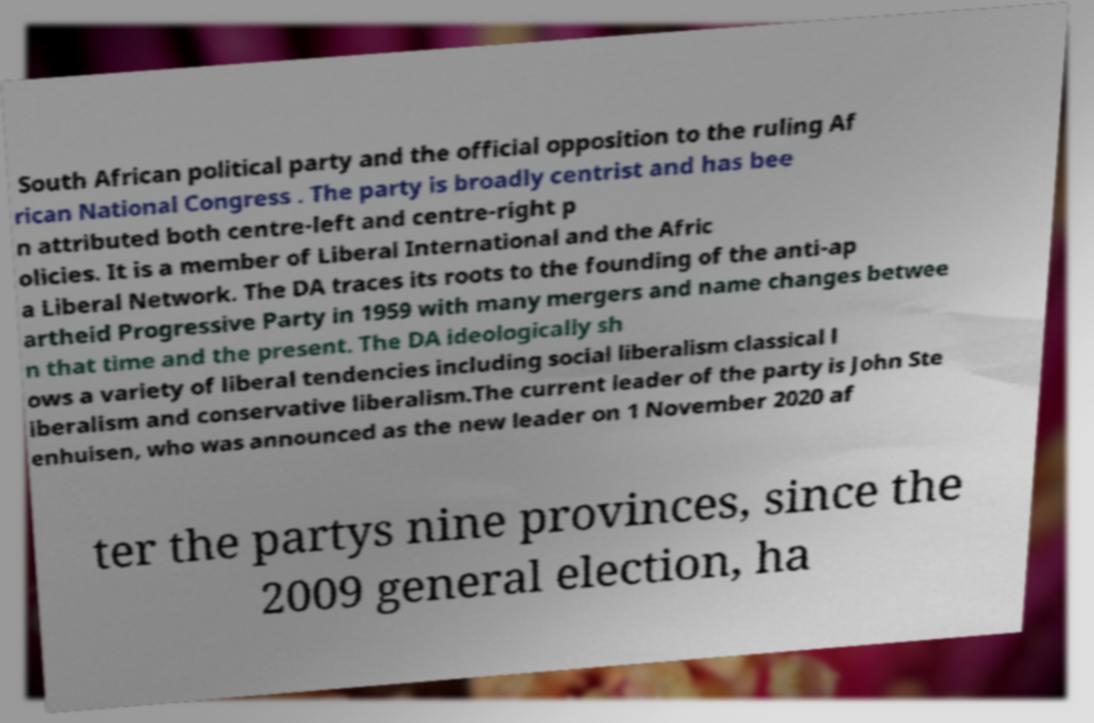Can you read and provide the text displayed in the image?This photo seems to have some interesting text. Can you extract and type it out for me? South African political party and the official opposition to the ruling Af rican National Congress . The party is broadly centrist and has bee n attributed both centre-left and centre-right p olicies. It is a member of Liberal International and the Afric a Liberal Network. The DA traces its roots to the founding of the anti-ap artheid Progressive Party in 1959 with many mergers and name changes betwee n that time and the present. The DA ideologically sh ows a variety of liberal tendencies including social liberalism classical l iberalism and conservative liberalism.The current leader of the party is John Ste enhuisen, who was announced as the new leader on 1 November 2020 af ter the partys nine provinces, since the 2009 general election, ha 